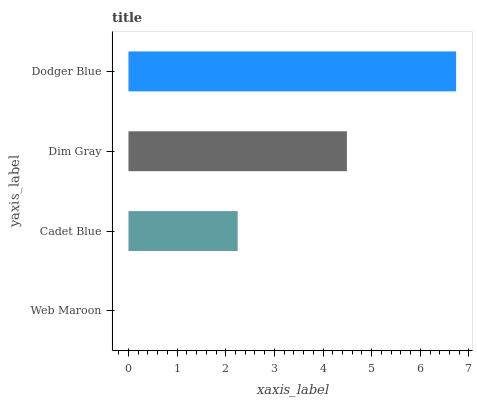Is Web Maroon the minimum?
Answer yes or no. Yes. Is Dodger Blue the maximum?
Answer yes or no. Yes. Is Cadet Blue the minimum?
Answer yes or no. No. Is Cadet Blue the maximum?
Answer yes or no. No. Is Cadet Blue greater than Web Maroon?
Answer yes or no. Yes. Is Web Maroon less than Cadet Blue?
Answer yes or no. Yes. Is Web Maroon greater than Cadet Blue?
Answer yes or no. No. Is Cadet Blue less than Web Maroon?
Answer yes or no. No. Is Dim Gray the high median?
Answer yes or no. Yes. Is Cadet Blue the low median?
Answer yes or no. Yes. Is Dodger Blue the high median?
Answer yes or no. No. Is Web Maroon the low median?
Answer yes or no. No. 